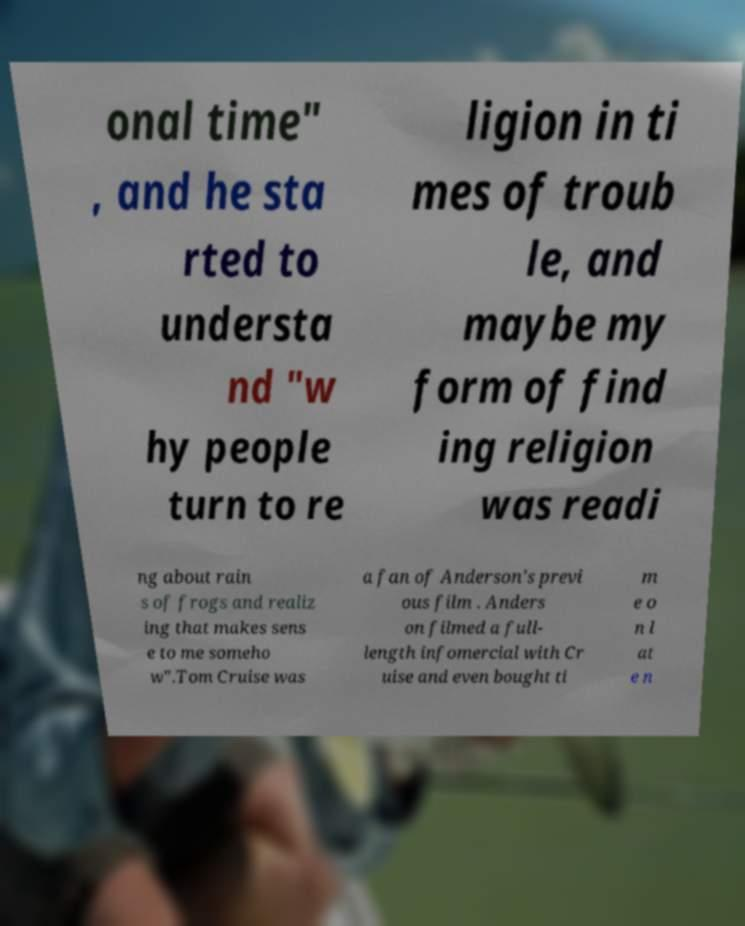There's text embedded in this image that I need extracted. Can you transcribe it verbatim? onal time" , and he sta rted to understa nd "w hy people turn to re ligion in ti mes of troub le, and maybe my form of find ing religion was readi ng about rain s of frogs and realiz ing that makes sens e to me someho w".Tom Cruise was a fan of Anderson's previ ous film . Anders on filmed a full- length infomercial with Cr uise and even bought ti m e o n l at e n 